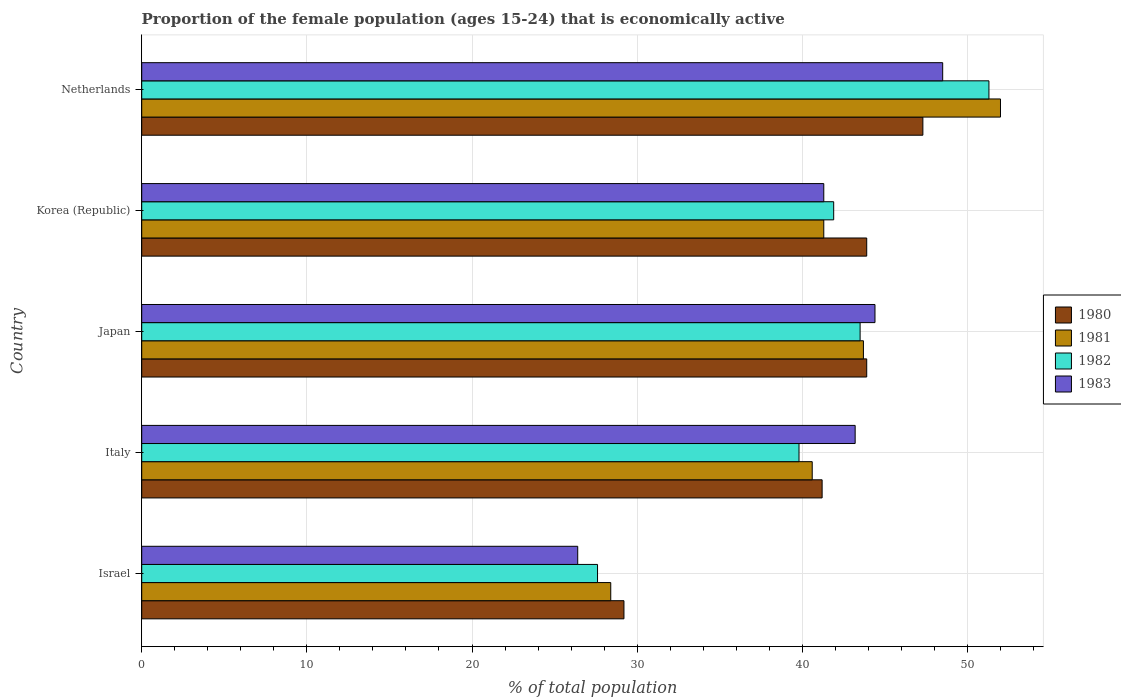Are the number of bars on each tick of the Y-axis equal?
Keep it short and to the point. Yes. What is the label of the 2nd group of bars from the top?
Make the answer very short. Korea (Republic). What is the proportion of the female population that is economically active in 1981 in Israel?
Give a very brief answer. 28.4. Across all countries, what is the maximum proportion of the female population that is economically active in 1983?
Offer a terse response. 48.5. Across all countries, what is the minimum proportion of the female population that is economically active in 1983?
Your response must be concise. 26.4. In which country was the proportion of the female population that is economically active in 1982 maximum?
Give a very brief answer. Netherlands. In which country was the proportion of the female population that is economically active in 1983 minimum?
Give a very brief answer. Israel. What is the total proportion of the female population that is economically active in 1982 in the graph?
Your answer should be compact. 204.1. What is the difference between the proportion of the female population that is economically active in 1982 in Israel and that in Italy?
Your answer should be compact. -12.2. What is the average proportion of the female population that is economically active in 1981 per country?
Offer a very short reply. 41.2. What is the difference between the proportion of the female population that is economically active in 1981 and proportion of the female population that is economically active in 1982 in Israel?
Your answer should be very brief. 0.8. In how many countries, is the proportion of the female population that is economically active in 1980 greater than 34 %?
Offer a very short reply. 4. What is the ratio of the proportion of the female population that is economically active in 1982 in Israel to that in Italy?
Offer a very short reply. 0.69. Is the difference between the proportion of the female population that is economically active in 1981 in Italy and Japan greater than the difference between the proportion of the female population that is economically active in 1982 in Italy and Japan?
Your response must be concise. Yes. What is the difference between the highest and the second highest proportion of the female population that is economically active in 1981?
Your response must be concise. 8.3. What is the difference between the highest and the lowest proportion of the female population that is economically active in 1983?
Your answer should be very brief. 22.1. Is the sum of the proportion of the female population that is economically active in 1980 in Japan and Netherlands greater than the maximum proportion of the female population that is economically active in 1981 across all countries?
Give a very brief answer. Yes. Is it the case that in every country, the sum of the proportion of the female population that is economically active in 1980 and proportion of the female population that is economically active in 1982 is greater than the sum of proportion of the female population that is economically active in 1981 and proportion of the female population that is economically active in 1983?
Give a very brief answer. No. What does the 3rd bar from the top in Israel represents?
Provide a succinct answer. 1981. What does the 4th bar from the bottom in Netherlands represents?
Provide a succinct answer. 1983. Are all the bars in the graph horizontal?
Offer a terse response. Yes. What is the difference between two consecutive major ticks on the X-axis?
Give a very brief answer. 10. Are the values on the major ticks of X-axis written in scientific E-notation?
Your response must be concise. No. Where does the legend appear in the graph?
Your response must be concise. Center right. How many legend labels are there?
Keep it short and to the point. 4. How are the legend labels stacked?
Your answer should be very brief. Vertical. What is the title of the graph?
Provide a short and direct response. Proportion of the female population (ages 15-24) that is economically active. Does "2009" appear as one of the legend labels in the graph?
Give a very brief answer. No. What is the label or title of the X-axis?
Your response must be concise. % of total population. What is the % of total population of 1980 in Israel?
Your response must be concise. 29.2. What is the % of total population of 1981 in Israel?
Your response must be concise. 28.4. What is the % of total population of 1982 in Israel?
Your answer should be very brief. 27.6. What is the % of total population of 1983 in Israel?
Offer a very short reply. 26.4. What is the % of total population in 1980 in Italy?
Ensure brevity in your answer.  41.2. What is the % of total population in 1981 in Italy?
Provide a succinct answer. 40.6. What is the % of total population in 1982 in Italy?
Your answer should be compact. 39.8. What is the % of total population of 1983 in Italy?
Offer a terse response. 43.2. What is the % of total population of 1980 in Japan?
Your response must be concise. 43.9. What is the % of total population of 1981 in Japan?
Offer a terse response. 43.7. What is the % of total population of 1982 in Japan?
Give a very brief answer. 43.5. What is the % of total population of 1983 in Japan?
Your answer should be compact. 44.4. What is the % of total population of 1980 in Korea (Republic)?
Make the answer very short. 43.9. What is the % of total population in 1981 in Korea (Republic)?
Give a very brief answer. 41.3. What is the % of total population in 1982 in Korea (Republic)?
Give a very brief answer. 41.9. What is the % of total population of 1983 in Korea (Republic)?
Provide a succinct answer. 41.3. What is the % of total population in 1980 in Netherlands?
Provide a short and direct response. 47.3. What is the % of total population in 1982 in Netherlands?
Your answer should be very brief. 51.3. What is the % of total population of 1983 in Netherlands?
Offer a terse response. 48.5. Across all countries, what is the maximum % of total population of 1980?
Your response must be concise. 47.3. Across all countries, what is the maximum % of total population of 1981?
Provide a succinct answer. 52. Across all countries, what is the maximum % of total population of 1982?
Keep it short and to the point. 51.3. Across all countries, what is the maximum % of total population of 1983?
Keep it short and to the point. 48.5. Across all countries, what is the minimum % of total population of 1980?
Your answer should be compact. 29.2. Across all countries, what is the minimum % of total population of 1981?
Your answer should be compact. 28.4. Across all countries, what is the minimum % of total population in 1982?
Offer a very short reply. 27.6. Across all countries, what is the minimum % of total population of 1983?
Ensure brevity in your answer.  26.4. What is the total % of total population in 1980 in the graph?
Provide a short and direct response. 205.5. What is the total % of total population of 1981 in the graph?
Your answer should be compact. 206. What is the total % of total population of 1982 in the graph?
Keep it short and to the point. 204.1. What is the total % of total population of 1983 in the graph?
Offer a terse response. 203.8. What is the difference between the % of total population of 1982 in Israel and that in Italy?
Keep it short and to the point. -12.2. What is the difference between the % of total population of 1983 in Israel and that in Italy?
Offer a terse response. -16.8. What is the difference between the % of total population of 1980 in Israel and that in Japan?
Give a very brief answer. -14.7. What is the difference between the % of total population in 1981 in Israel and that in Japan?
Your answer should be very brief. -15.3. What is the difference between the % of total population of 1982 in Israel and that in Japan?
Provide a succinct answer. -15.9. What is the difference between the % of total population of 1980 in Israel and that in Korea (Republic)?
Your response must be concise. -14.7. What is the difference between the % of total population of 1982 in Israel and that in Korea (Republic)?
Ensure brevity in your answer.  -14.3. What is the difference between the % of total population of 1983 in Israel and that in Korea (Republic)?
Your answer should be very brief. -14.9. What is the difference between the % of total population of 1980 in Israel and that in Netherlands?
Provide a succinct answer. -18.1. What is the difference between the % of total population of 1981 in Israel and that in Netherlands?
Your answer should be very brief. -23.6. What is the difference between the % of total population in 1982 in Israel and that in Netherlands?
Give a very brief answer. -23.7. What is the difference between the % of total population of 1983 in Israel and that in Netherlands?
Your answer should be very brief. -22.1. What is the difference between the % of total population in 1980 in Italy and that in Japan?
Offer a terse response. -2.7. What is the difference between the % of total population of 1981 in Italy and that in Japan?
Your answer should be very brief. -3.1. What is the difference between the % of total population of 1982 in Italy and that in Japan?
Ensure brevity in your answer.  -3.7. What is the difference between the % of total population of 1980 in Italy and that in Korea (Republic)?
Your response must be concise. -2.7. What is the difference between the % of total population in 1981 in Italy and that in Korea (Republic)?
Give a very brief answer. -0.7. What is the difference between the % of total population of 1980 in Italy and that in Netherlands?
Provide a succinct answer. -6.1. What is the difference between the % of total population in 1982 in Italy and that in Netherlands?
Your answer should be compact. -11.5. What is the difference between the % of total population of 1983 in Italy and that in Netherlands?
Your answer should be compact. -5.3. What is the difference between the % of total population in 1981 in Japan and that in Netherlands?
Your answer should be compact. -8.3. What is the difference between the % of total population of 1983 in Japan and that in Netherlands?
Your answer should be compact. -4.1. What is the difference between the % of total population of 1982 in Korea (Republic) and that in Netherlands?
Offer a very short reply. -9.4. What is the difference between the % of total population of 1980 in Israel and the % of total population of 1981 in Italy?
Your response must be concise. -11.4. What is the difference between the % of total population of 1980 in Israel and the % of total population of 1982 in Italy?
Provide a succinct answer. -10.6. What is the difference between the % of total population in 1981 in Israel and the % of total population in 1983 in Italy?
Keep it short and to the point. -14.8. What is the difference between the % of total population of 1982 in Israel and the % of total population of 1983 in Italy?
Your response must be concise. -15.6. What is the difference between the % of total population in 1980 in Israel and the % of total population in 1981 in Japan?
Your answer should be compact. -14.5. What is the difference between the % of total population in 1980 in Israel and the % of total population in 1982 in Japan?
Offer a very short reply. -14.3. What is the difference between the % of total population in 1980 in Israel and the % of total population in 1983 in Japan?
Your answer should be very brief. -15.2. What is the difference between the % of total population of 1981 in Israel and the % of total population of 1982 in Japan?
Make the answer very short. -15.1. What is the difference between the % of total population of 1982 in Israel and the % of total population of 1983 in Japan?
Provide a short and direct response. -16.8. What is the difference between the % of total population in 1980 in Israel and the % of total population in 1981 in Korea (Republic)?
Your answer should be very brief. -12.1. What is the difference between the % of total population of 1980 in Israel and the % of total population of 1982 in Korea (Republic)?
Offer a very short reply. -12.7. What is the difference between the % of total population of 1980 in Israel and the % of total population of 1983 in Korea (Republic)?
Offer a very short reply. -12.1. What is the difference between the % of total population in 1982 in Israel and the % of total population in 1983 in Korea (Republic)?
Ensure brevity in your answer.  -13.7. What is the difference between the % of total population of 1980 in Israel and the % of total population of 1981 in Netherlands?
Your answer should be compact. -22.8. What is the difference between the % of total population in 1980 in Israel and the % of total population in 1982 in Netherlands?
Give a very brief answer. -22.1. What is the difference between the % of total population in 1980 in Israel and the % of total population in 1983 in Netherlands?
Offer a terse response. -19.3. What is the difference between the % of total population of 1981 in Israel and the % of total population of 1982 in Netherlands?
Your answer should be very brief. -22.9. What is the difference between the % of total population in 1981 in Israel and the % of total population in 1983 in Netherlands?
Your answer should be compact. -20.1. What is the difference between the % of total population of 1982 in Israel and the % of total population of 1983 in Netherlands?
Give a very brief answer. -20.9. What is the difference between the % of total population in 1981 in Italy and the % of total population in 1982 in Japan?
Your answer should be compact. -2.9. What is the difference between the % of total population in 1981 in Italy and the % of total population in 1983 in Japan?
Offer a terse response. -3.8. What is the difference between the % of total population in 1982 in Italy and the % of total population in 1983 in Japan?
Provide a succinct answer. -4.6. What is the difference between the % of total population in 1980 in Italy and the % of total population in 1982 in Korea (Republic)?
Your answer should be very brief. -0.7. What is the difference between the % of total population of 1980 in Italy and the % of total population of 1983 in Korea (Republic)?
Your response must be concise. -0.1. What is the difference between the % of total population in 1981 in Italy and the % of total population in 1982 in Korea (Republic)?
Keep it short and to the point. -1.3. What is the difference between the % of total population in 1980 in Japan and the % of total population in 1981 in Korea (Republic)?
Provide a short and direct response. 2.6. What is the difference between the % of total population of 1980 in Japan and the % of total population of 1983 in Korea (Republic)?
Ensure brevity in your answer.  2.6. What is the difference between the % of total population in 1981 in Japan and the % of total population in 1983 in Korea (Republic)?
Keep it short and to the point. 2.4. What is the difference between the % of total population in 1982 in Japan and the % of total population in 1983 in Korea (Republic)?
Your answer should be compact. 2.2. What is the difference between the % of total population of 1980 in Japan and the % of total population of 1981 in Netherlands?
Make the answer very short. -8.1. What is the difference between the % of total population in 1980 in Japan and the % of total population in 1983 in Netherlands?
Give a very brief answer. -4.6. What is the difference between the % of total population in 1981 in Japan and the % of total population in 1983 in Netherlands?
Offer a very short reply. -4.8. What is the difference between the % of total population in 1981 in Korea (Republic) and the % of total population in 1983 in Netherlands?
Give a very brief answer. -7.2. What is the average % of total population of 1980 per country?
Your answer should be compact. 41.1. What is the average % of total population of 1981 per country?
Ensure brevity in your answer.  41.2. What is the average % of total population of 1982 per country?
Your answer should be compact. 40.82. What is the average % of total population of 1983 per country?
Your answer should be very brief. 40.76. What is the difference between the % of total population of 1980 and % of total population of 1981 in Israel?
Your response must be concise. 0.8. What is the difference between the % of total population in 1981 and % of total population in 1983 in Israel?
Keep it short and to the point. 2. What is the difference between the % of total population of 1982 and % of total population of 1983 in Israel?
Make the answer very short. 1.2. What is the difference between the % of total population in 1980 and % of total population in 1981 in Italy?
Make the answer very short. 0.6. What is the difference between the % of total population of 1980 and % of total population of 1982 in Italy?
Give a very brief answer. 1.4. What is the difference between the % of total population of 1981 and % of total population of 1982 in Italy?
Keep it short and to the point. 0.8. What is the difference between the % of total population of 1981 and % of total population of 1983 in Italy?
Keep it short and to the point. -2.6. What is the difference between the % of total population of 1982 and % of total population of 1983 in Japan?
Your answer should be very brief. -0.9. What is the difference between the % of total population of 1980 and % of total population of 1981 in Korea (Republic)?
Provide a short and direct response. 2.6. What is the difference between the % of total population in 1981 and % of total population in 1983 in Korea (Republic)?
Keep it short and to the point. 0. What is the ratio of the % of total population in 1980 in Israel to that in Italy?
Make the answer very short. 0.71. What is the ratio of the % of total population of 1981 in Israel to that in Italy?
Your answer should be compact. 0.7. What is the ratio of the % of total population in 1982 in Israel to that in Italy?
Your answer should be compact. 0.69. What is the ratio of the % of total population of 1983 in Israel to that in Italy?
Your response must be concise. 0.61. What is the ratio of the % of total population of 1980 in Israel to that in Japan?
Offer a terse response. 0.67. What is the ratio of the % of total population of 1981 in Israel to that in Japan?
Your response must be concise. 0.65. What is the ratio of the % of total population of 1982 in Israel to that in Japan?
Offer a terse response. 0.63. What is the ratio of the % of total population in 1983 in Israel to that in Japan?
Give a very brief answer. 0.59. What is the ratio of the % of total population of 1980 in Israel to that in Korea (Republic)?
Provide a short and direct response. 0.67. What is the ratio of the % of total population of 1981 in Israel to that in Korea (Republic)?
Make the answer very short. 0.69. What is the ratio of the % of total population of 1982 in Israel to that in Korea (Republic)?
Provide a short and direct response. 0.66. What is the ratio of the % of total population in 1983 in Israel to that in Korea (Republic)?
Your response must be concise. 0.64. What is the ratio of the % of total population of 1980 in Israel to that in Netherlands?
Ensure brevity in your answer.  0.62. What is the ratio of the % of total population of 1981 in Israel to that in Netherlands?
Keep it short and to the point. 0.55. What is the ratio of the % of total population in 1982 in Israel to that in Netherlands?
Give a very brief answer. 0.54. What is the ratio of the % of total population of 1983 in Israel to that in Netherlands?
Your response must be concise. 0.54. What is the ratio of the % of total population of 1980 in Italy to that in Japan?
Ensure brevity in your answer.  0.94. What is the ratio of the % of total population in 1981 in Italy to that in Japan?
Your response must be concise. 0.93. What is the ratio of the % of total population in 1982 in Italy to that in Japan?
Your response must be concise. 0.91. What is the ratio of the % of total population in 1983 in Italy to that in Japan?
Give a very brief answer. 0.97. What is the ratio of the % of total population in 1980 in Italy to that in Korea (Republic)?
Make the answer very short. 0.94. What is the ratio of the % of total population of 1981 in Italy to that in Korea (Republic)?
Make the answer very short. 0.98. What is the ratio of the % of total population in 1982 in Italy to that in Korea (Republic)?
Provide a succinct answer. 0.95. What is the ratio of the % of total population of 1983 in Italy to that in Korea (Republic)?
Make the answer very short. 1.05. What is the ratio of the % of total population in 1980 in Italy to that in Netherlands?
Ensure brevity in your answer.  0.87. What is the ratio of the % of total population of 1981 in Italy to that in Netherlands?
Keep it short and to the point. 0.78. What is the ratio of the % of total population of 1982 in Italy to that in Netherlands?
Ensure brevity in your answer.  0.78. What is the ratio of the % of total population in 1983 in Italy to that in Netherlands?
Ensure brevity in your answer.  0.89. What is the ratio of the % of total population of 1981 in Japan to that in Korea (Republic)?
Offer a very short reply. 1.06. What is the ratio of the % of total population of 1982 in Japan to that in Korea (Republic)?
Your answer should be compact. 1.04. What is the ratio of the % of total population of 1983 in Japan to that in Korea (Republic)?
Your response must be concise. 1.08. What is the ratio of the % of total population in 1980 in Japan to that in Netherlands?
Keep it short and to the point. 0.93. What is the ratio of the % of total population in 1981 in Japan to that in Netherlands?
Keep it short and to the point. 0.84. What is the ratio of the % of total population in 1982 in Japan to that in Netherlands?
Give a very brief answer. 0.85. What is the ratio of the % of total population of 1983 in Japan to that in Netherlands?
Provide a succinct answer. 0.92. What is the ratio of the % of total population of 1980 in Korea (Republic) to that in Netherlands?
Make the answer very short. 0.93. What is the ratio of the % of total population in 1981 in Korea (Republic) to that in Netherlands?
Keep it short and to the point. 0.79. What is the ratio of the % of total population in 1982 in Korea (Republic) to that in Netherlands?
Your response must be concise. 0.82. What is the ratio of the % of total population in 1983 in Korea (Republic) to that in Netherlands?
Make the answer very short. 0.85. What is the difference between the highest and the second highest % of total population in 1981?
Keep it short and to the point. 8.3. What is the difference between the highest and the second highest % of total population in 1982?
Keep it short and to the point. 7.8. What is the difference between the highest and the lowest % of total population of 1981?
Keep it short and to the point. 23.6. What is the difference between the highest and the lowest % of total population in 1982?
Keep it short and to the point. 23.7. What is the difference between the highest and the lowest % of total population in 1983?
Keep it short and to the point. 22.1. 